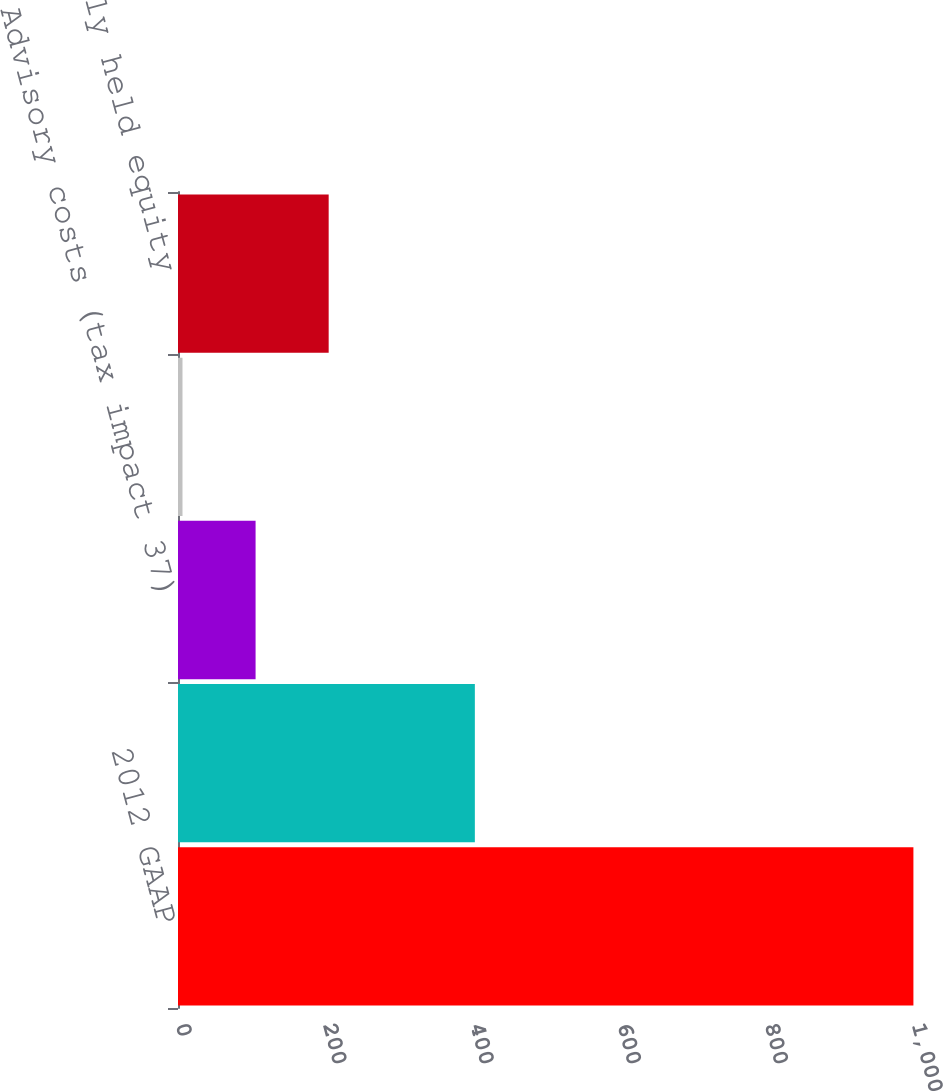Convert chart to OTSL. <chart><loc_0><loc_0><loc_500><loc_500><bar_chart><fcel>2012 GAAP<fcel>Business restructuring and<fcel>Advisory costs (tax impact 37)<fcel>Customer bankruptcy (tax<fcel>Gain on previously held equity<nl><fcel>999.2<fcel>403.34<fcel>105.41<fcel>6.1<fcel>204.72<nl></chart> 